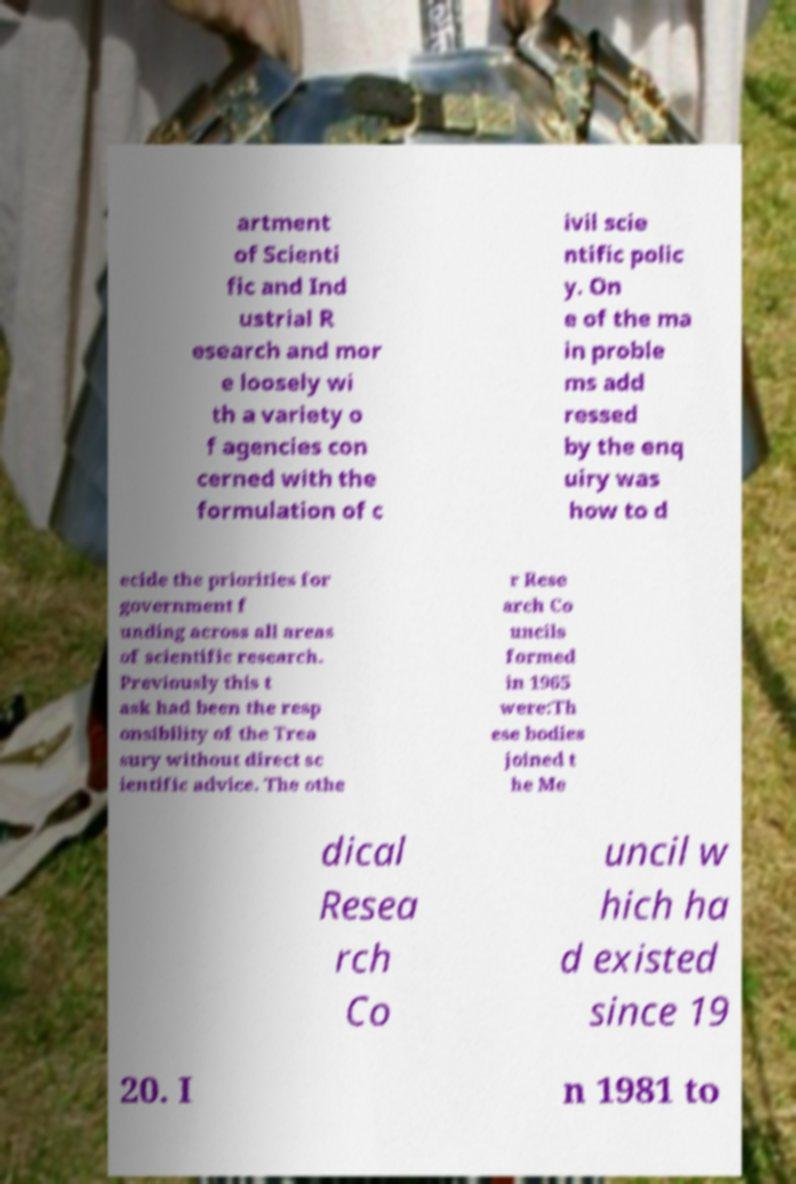Please read and relay the text visible in this image. What does it say? artment of Scienti fic and Ind ustrial R esearch and mor e loosely wi th a variety o f agencies con cerned with the formulation of c ivil scie ntific polic y. On e of the ma in proble ms add ressed by the enq uiry was how to d ecide the priorities for government f unding across all areas of scientific research. Previously this t ask had been the resp onsibility of the Trea sury without direct sc ientific advice. The othe r Rese arch Co uncils formed in 1965 were:Th ese bodies joined t he Me dical Resea rch Co uncil w hich ha d existed since 19 20. I n 1981 to 